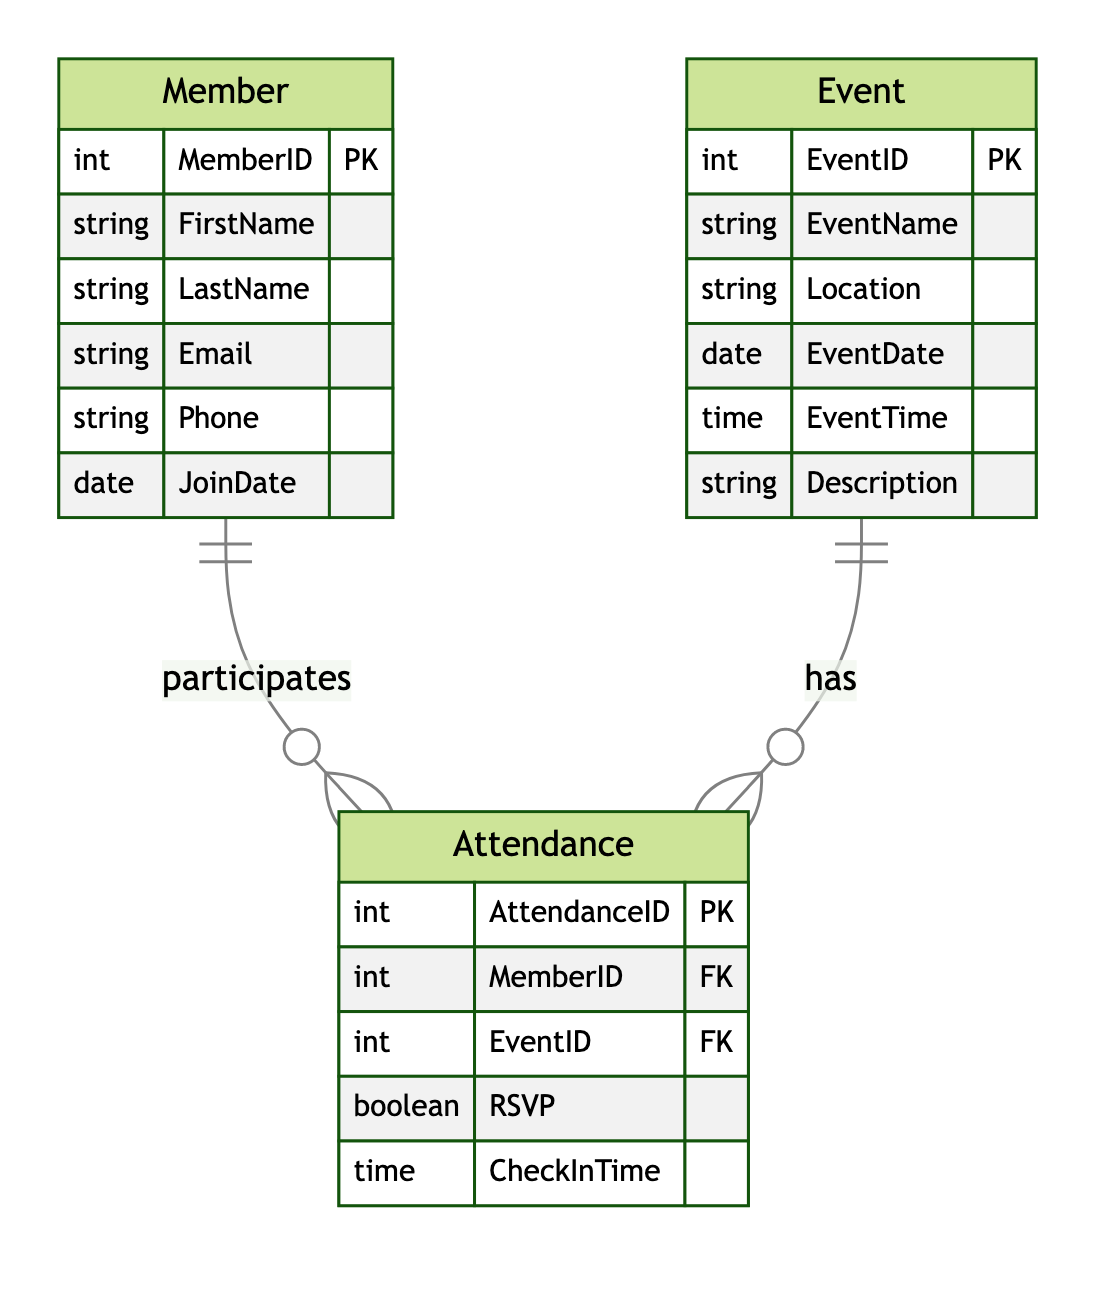What is the primary key of the Member entity? The primary key of the Member entity is indicated by "PK" next to the "MemberID" attribute in the diagram. This signifies that "MemberID" uniquely identifies each member.
Answer: MemberID How many attributes does the Event entity have? The Event entity lists six attributes: EventID, EventName, Location, EventDate, EventTime, and Description. Counting each one gives the total.
Answer: 6 What type of relationship exists between Member and Event? The diagram specifies a many-to-many relationship between Member and Event, indicated by the symbols connecting the two entities. This signifies that a member can attend many events, and an event can have many members attending.
Answer: many-to-many Which entity has a "JoinDate" attribute? By examining the listed attributes of each entity, the "JoinDate" attribute is found in the Member entity only, indicating when members joined the group.
Answer: Member What does the Attendance entity connect? The Attendance entity serves as a connection between the Member and Event entities as a junction table, facilitating the many-to-many relationship between them.
Answer: Member and Event How many entities are present in the diagram? The diagram presents three distinct entities: Member, Event, and Attendance. This count reflects the various functional components represented.
Answer: 3 What is the primary key of the Attendance entity? The primary key of the Attendance entity is identified as "AttendanceID," marked with "PK." This denotes the unique identifier for each attendance record in the entity.
Answer: AttendanceID What foreign keys are present in the Attendance entity? The Attendance entity contains two foreign keys, "MemberID" and "EventID," which establish relationships with the Member and Event entities respectively.
Answer: MemberID and EventID What time-related attribute does the Attendance entity have? The Attendance entity includes the "CheckInTime" attribute, which tracks the time a member checks in for an event. This attribute is specifically related to attendance records.
Answer: CheckInTime 